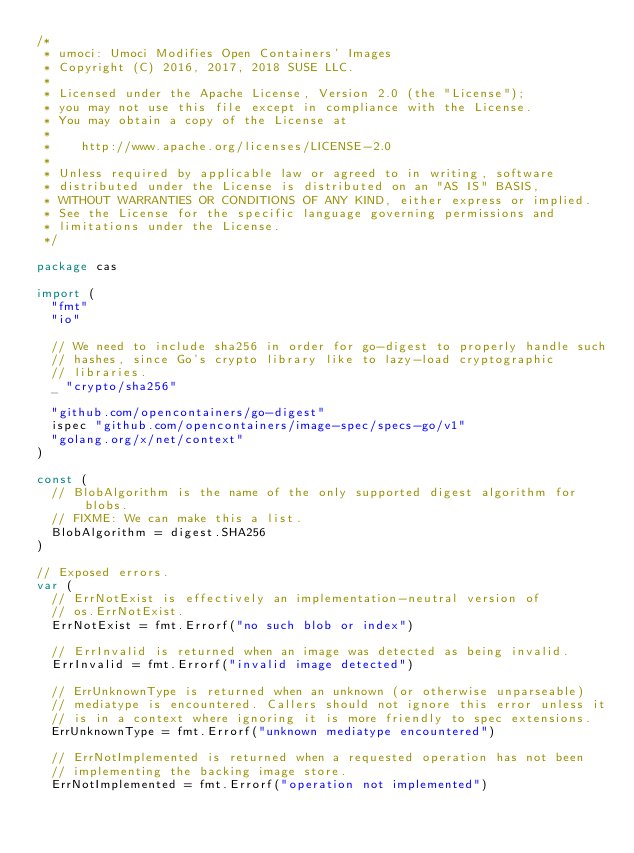Convert code to text. <code><loc_0><loc_0><loc_500><loc_500><_Go_>/*
 * umoci: Umoci Modifies Open Containers' Images
 * Copyright (C) 2016, 2017, 2018 SUSE LLC.
 *
 * Licensed under the Apache License, Version 2.0 (the "License");
 * you may not use this file except in compliance with the License.
 * You may obtain a copy of the License at
 *
 *    http://www.apache.org/licenses/LICENSE-2.0
 *
 * Unless required by applicable law or agreed to in writing, software
 * distributed under the License is distributed on an "AS IS" BASIS,
 * WITHOUT WARRANTIES OR CONDITIONS OF ANY KIND, either express or implied.
 * See the License for the specific language governing permissions and
 * limitations under the License.
 */

package cas

import (
	"fmt"
	"io"

	// We need to include sha256 in order for go-digest to properly handle such
	// hashes, since Go's crypto library like to lazy-load cryptographic
	// libraries.
	_ "crypto/sha256"

	"github.com/opencontainers/go-digest"
	ispec "github.com/opencontainers/image-spec/specs-go/v1"
	"golang.org/x/net/context"
)

const (
	// BlobAlgorithm is the name of the only supported digest algorithm for blobs.
	// FIXME: We can make this a list.
	BlobAlgorithm = digest.SHA256
)

// Exposed errors.
var (
	// ErrNotExist is effectively an implementation-neutral version of
	// os.ErrNotExist.
	ErrNotExist = fmt.Errorf("no such blob or index")

	// ErrInvalid is returned when an image was detected as being invalid.
	ErrInvalid = fmt.Errorf("invalid image detected")

	// ErrUnknownType is returned when an unknown (or otherwise unparseable)
	// mediatype is encountered. Callers should not ignore this error unless it
	// is in a context where ignoring it is more friendly to spec extensions.
	ErrUnknownType = fmt.Errorf("unknown mediatype encountered")

	// ErrNotImplemented is returned when a requested operation has not been
	// implementing the backing image store.
	ErrNotImplemented = fmt.Errorf("operation not implemented")
</code> 